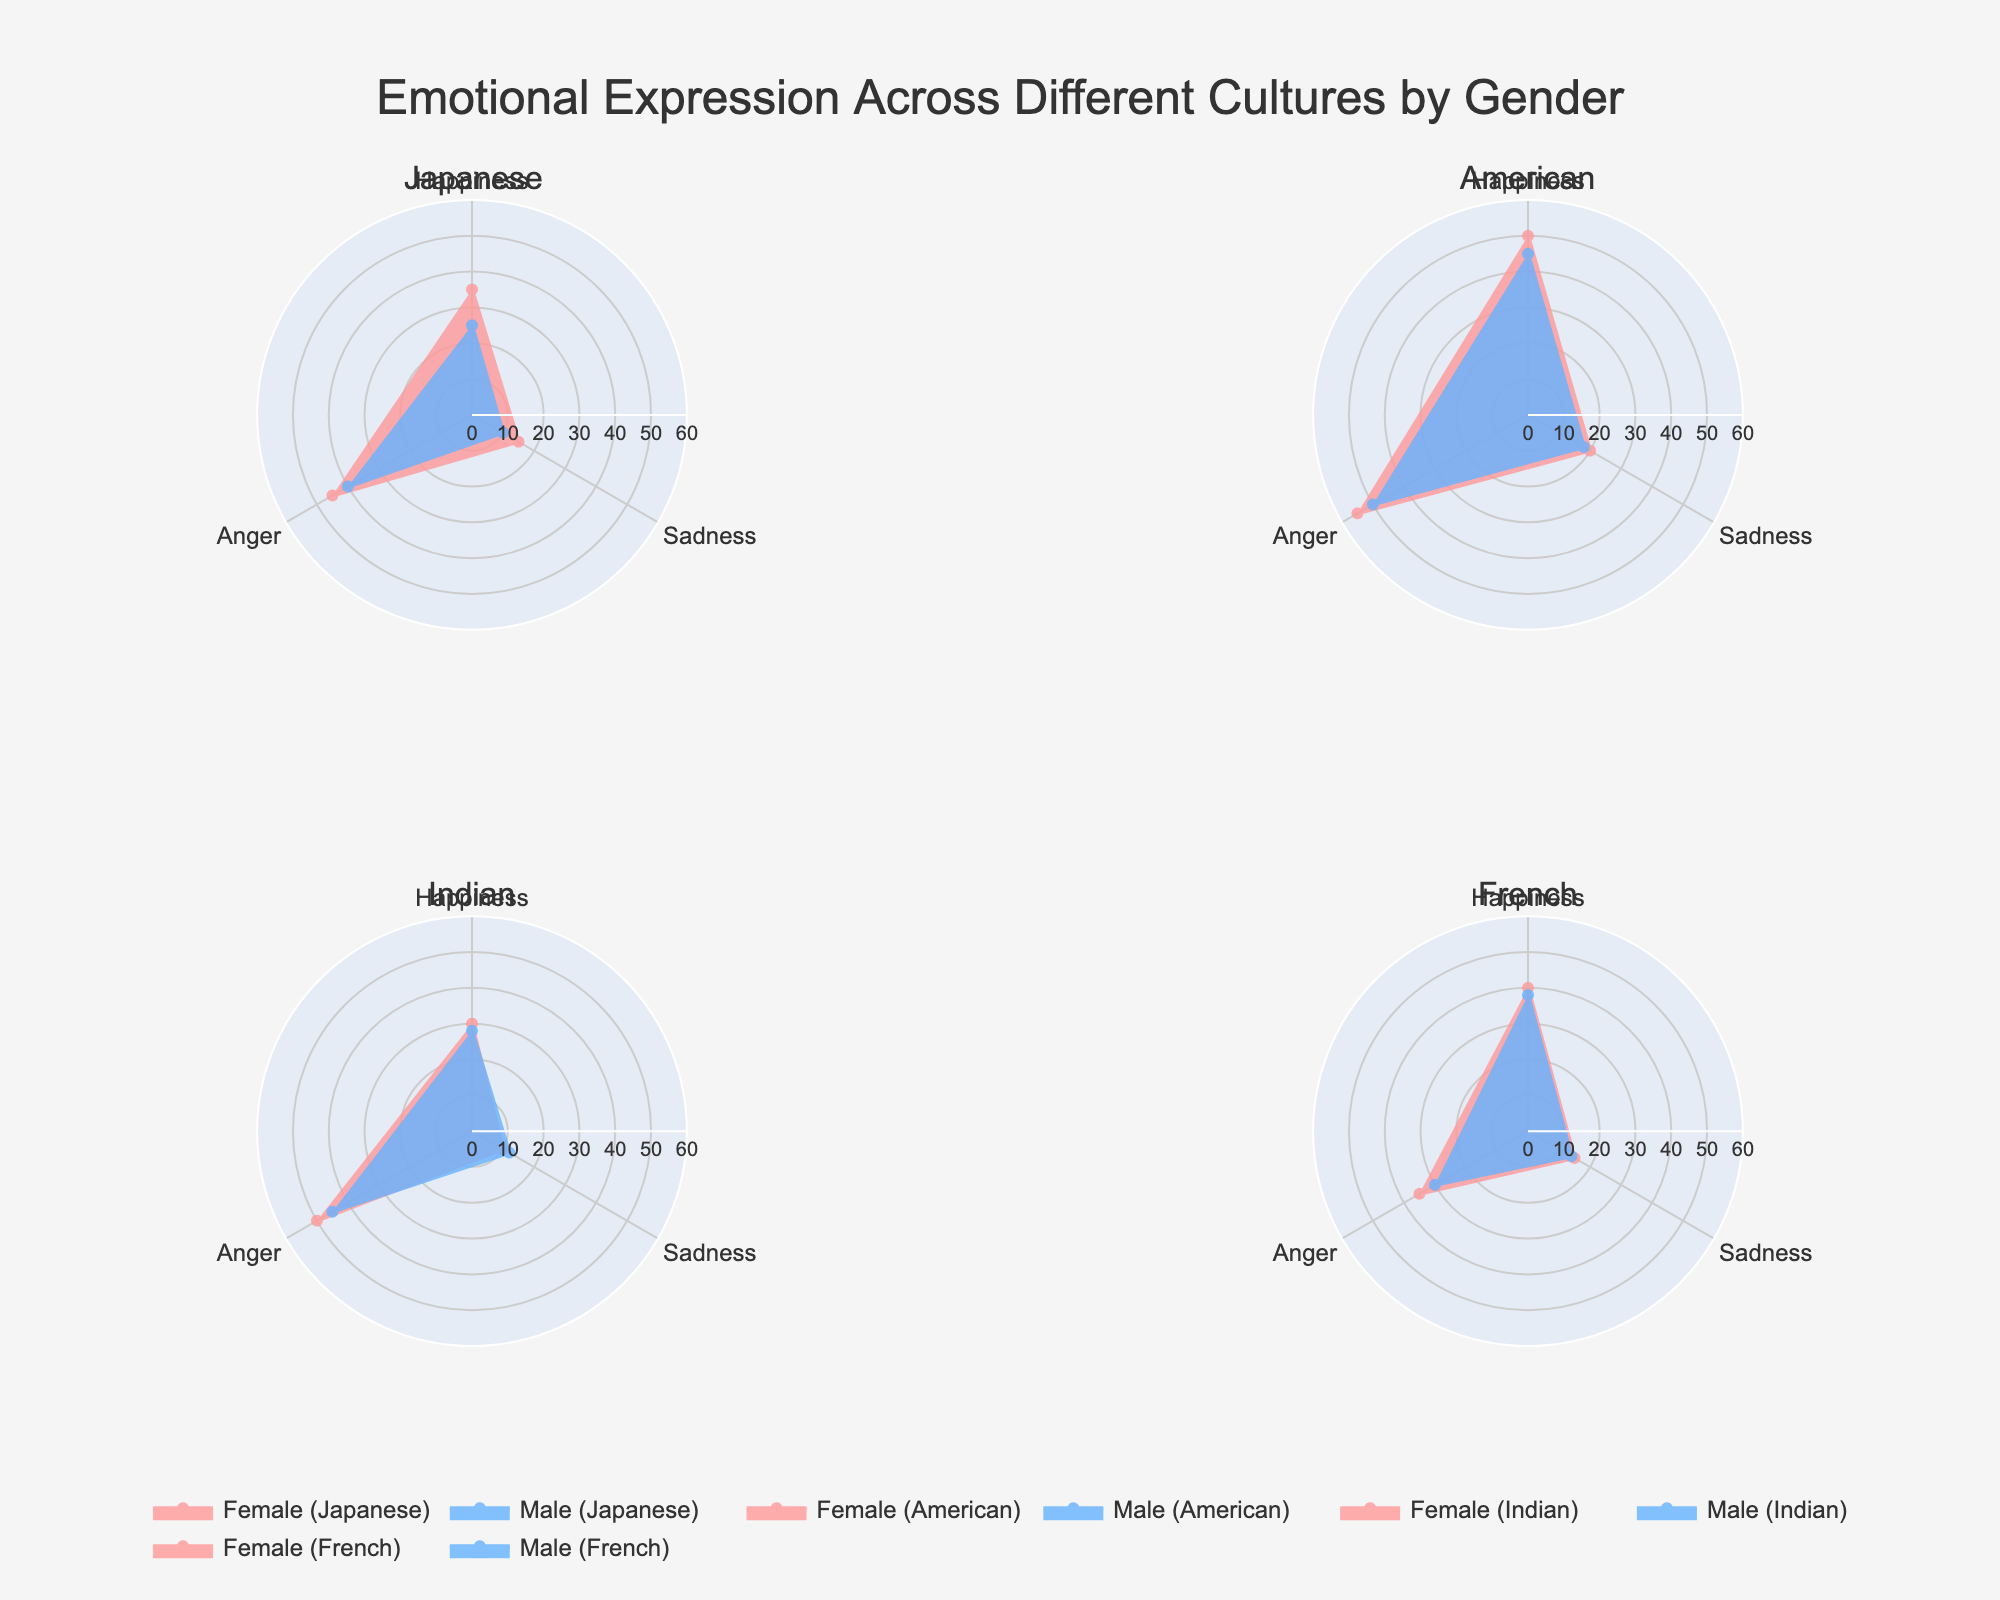Which gender shows higher frequency of happiness in American culture? Compare the 'Happiness' frequency values for American female and male, which are 50 and 45 respectively. Thus, American females show a higher frequency.
Answer: American females Which gender expresses anger more frequently in Japanese culture? Compare the 'Anger' frequency values for Japanese female and male, which are 45 and 40 respectively. Thus, Japanese females express anger more frequently.
Answer: Japanese females What emotion do Indian females express most frequently? Look at the values for Indian females: Happiness (30), Sadness (10), and Anger (50). Anger has the highest value.
Answer: Anger What is the combined frequency of sadness expression for French males and females? Add the 'Sadness' frequency values for French females (15) and males (14). Thus, the combined frequency is 15+14=29.
Answer: 29 Across all cultures, which gender shows a higher frequency of emotional expression in social gatherings? Compare the total 'Happiness' frequencies for females and males across all cultures. Female: 35+50+30+40 = 155, Male: 25+45+28+38 = 136. Thus, females show a higher frequency.
Answer: Females Which culture shows the least frequency of sadness expression at the workplace? Identify the 'Sadness' frequency values for each culture and both genders: Japanese (15, 10), American (20, 18), Indian (10, 12), French (15, 14). The lowest value is Japanese males (10).
Answer: Japanese males For American males, which emotion is expressed most frequently? Compare 'Happiness' (45), 'Sadness' (18), and 'Anger' (50) for American males. 'Anger' has the highest frequency.
Answer: Anger How does the frequency of anger expression in family interactions between Indian males and French males compare? Compare the 'Anger' frequency values for Indian males (45) and French males (30). Thus, Indian males express anger more frequently.
Answer: Indian males What is the difference in frequency between Japanese males and females in expressing anger? Subtract the 'Anger' frequency values for Japanese males (40) and females (45). The difference is 45-40=5.
Answer: 5 Which gender shows a greater variety of emotion types in the Japanese culture? Both genders display the same emotion types (Happiness, Sadness, Anger). Thus, the variety is equal.
Answer: Equal 